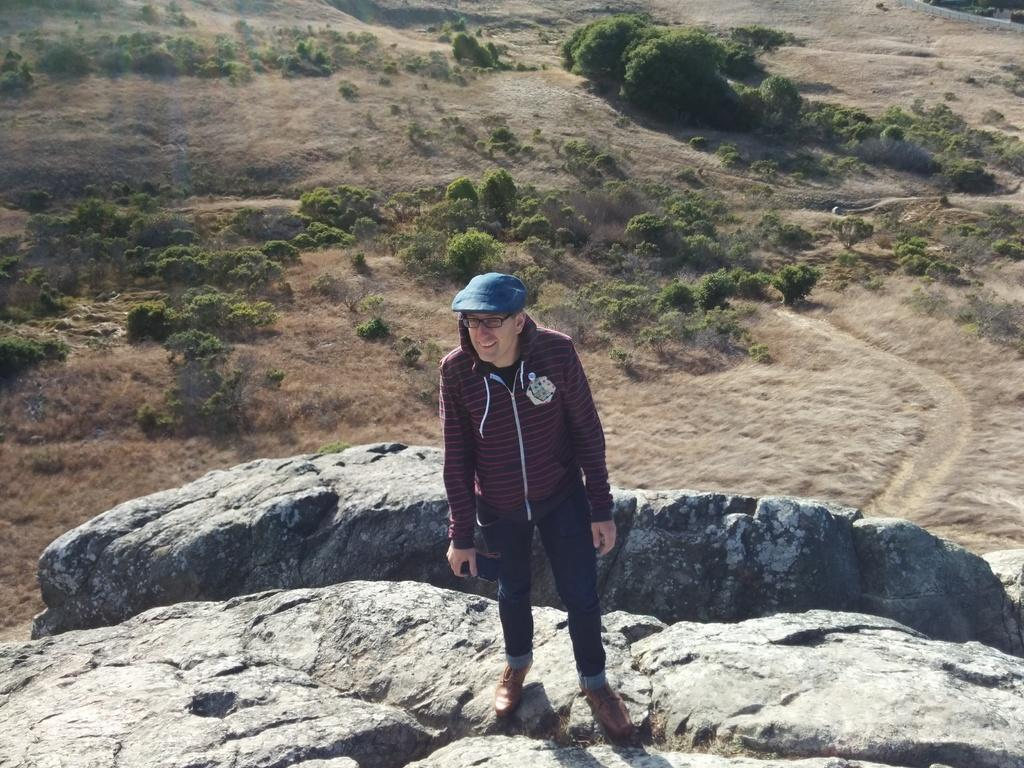Who is the main subject in the image? There is a man in the center of the image. What is the man standing on? The man is on a rock. What can be seen in the background of the image? There are plants in the background of the image. What type of lipstick is the woman wearing in the image? There is no woman present in the image, and therefore no lipstick or woman wearing lipstick can be observed. 